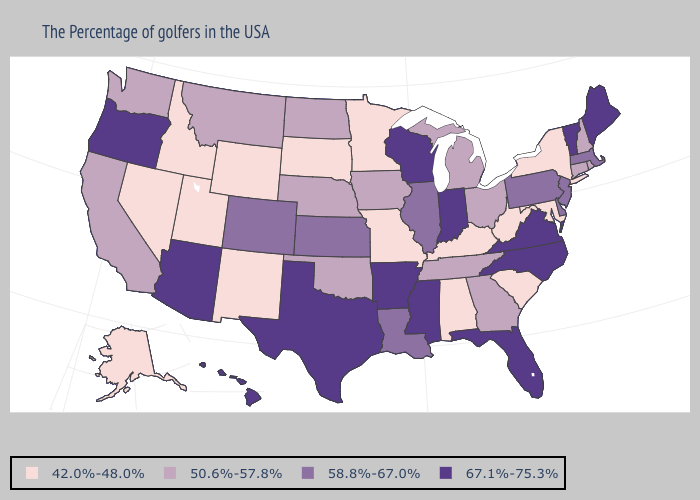Which states have the lowest value in the USA?
Short answer required. New York, Maryland, South Carolina, West Virginia, Kentucky, Alabama, Missouri, Minnesota, South Dakota, Wyoming, New Mexico, Utah, Idaho, Nevada, Alaska. Name the states that have a value in the range 50.6%-57.8%?
Concise answer only. Rhode Island, New Hampshire, Connecticut, Ohio, Georgia, Michigan, Tennessee, Iowa, Nebraska, Oklahoma, North Dakota, Montana, California, Washington. Name the states that have a value in the range 42.0%-48.0%?
Answer briefly. New York, Maryland, South Carolina, West Virginia, Kentucky, Alabama, Missouri, Minnesota, South Dakota, Wyoming, New Mexico, Utah, Idaho, Nevada, Alaska. Name the states that have a value in the range 58.8%-67.0%?
Quick response, please. Massachusetts, New Jersey, Delaware, Pennsylvania, Illinois, Louisiana, Kansas, Colorado. Which states have the highest value in the USA?
Keep it brief. Maine, Vermont, Virginia, North Carolina, Florida, Indiana, Wisconsin, Mississippi, Arkansas, Texas, Arizona, Oregon, Hawaii. Which states have the lowest value in the MidWest?
Give a very brief answer. Missouri, Minnesota, South Dakota. Name the states that have a value in the range 58.8%-67.0%?
Short answer required. Massachusetts, New Jersey, Delaware, Pennsylvania, Illinois, Louisiana, Kansas, Colorado. Does Illinois have the highest value in the USA?
Short answer required. No. Does Utah have the lowest value in the West?
Give a very brief answer. Yes. Name the states that have a value in the range 50.6%-57.8%?
Concise answer only. Rhode Island, New Hampshire, Connecticut, Ohio, Georgia, Michigan, Tennessee, Iowa, Nebraska, Oklahoma, North Dakota, Montana, California, Washington. Does the map have missing data?
Give a very brief answer. No. What is the value of Wyoming?
Answer briefly. 42.0%-48.0%. What is the value of Massachusetts?
Concise answer only. 58.8%-67.0%. Name the states that have a value in the range 50.6%-57.8%?
Concise answer only. Rhode Island, New Hampshire, Connecticut, Ohio, Georgia, Michigan, Tennessee, Iowa, Nebraska, Oklahoma, North Dakota, Montana, California, Washington. Name the states that have a value in the range 50.6%-57.8%?
Answer briefly. Rhode Island, New Hampshire, Connecticut, Ohio, Georgia, Michigan, Tennessee, Iowa, Nebraska, Oklahoma, North Dakota, Montana, California, Washington. 